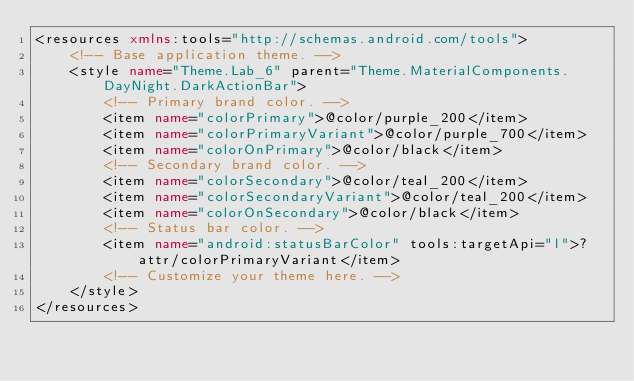<code> <loc_0><loc_0><loc_500><loc_500><_XML_><resources xmlns:tools="http://schemas.android.com/tools">
    <!-- Base application theme. -->
    <style name="Theme.Lab_6" parent="Theme.MaterialComponents.DayNight.DarkActionBar">
        <!-- Primary brand color. -->
        <item name="colorPrimary">@color/purple_200</item>
        <item name="colorPrimaryVariant">@color/purple_700</item>
        <item name="colorOnPrimary">@color/black</item>
        <!-- Secondary brand color. -->
        <item name="colorSecondary">@color/teal_200</item>
        <item name="colorSecondaryVariant">@color/teal_200</item>
        <item name="colorOnSecondary">@color/black</item>
        <!-- Status bar color. -->
        <item name="android:statusBarColor" tools:targetApi="l">?attr/colorPrimaryVariant</item>
        <!-- Customize your theme here. -->
    </style>
</resources></code> 